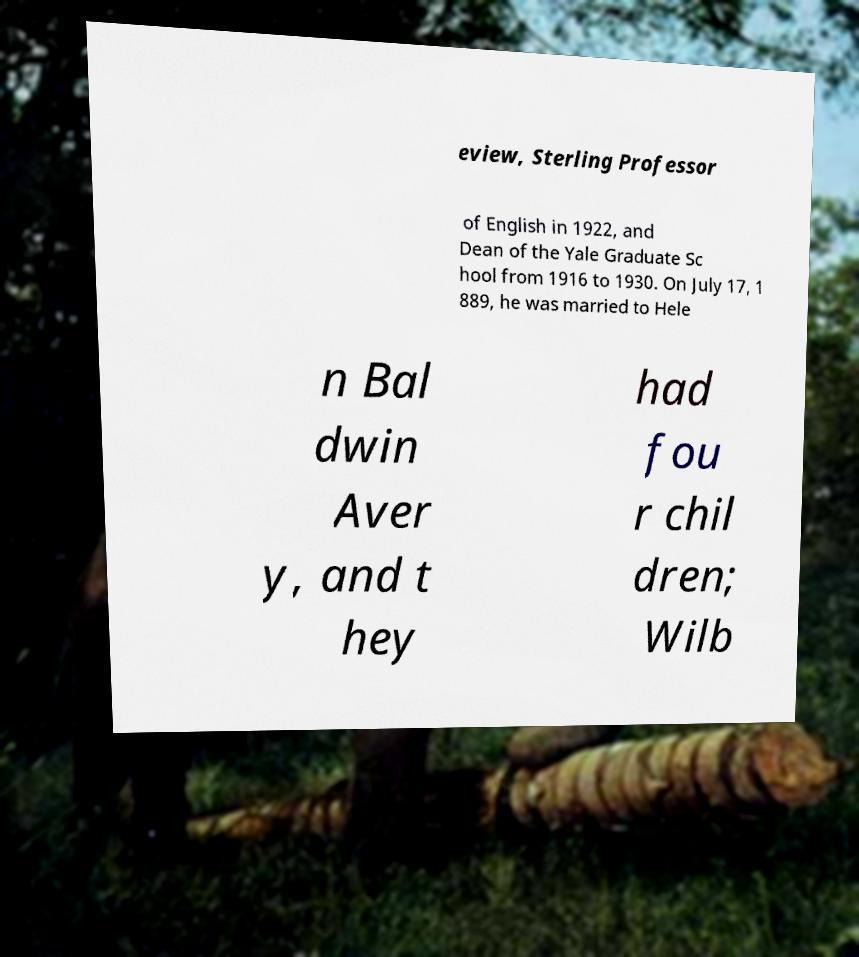Could you assist in decoding the text presented in this image and type it out clearly? eview, Sterling Professor of English in 1922, and Dean of the Yale Graduate Sc hool from 1916 to 1930. On July 17, 1 889, he was married to Hele n Bal dwin Aver y, and t hey had fou r chil dren; Wilb 